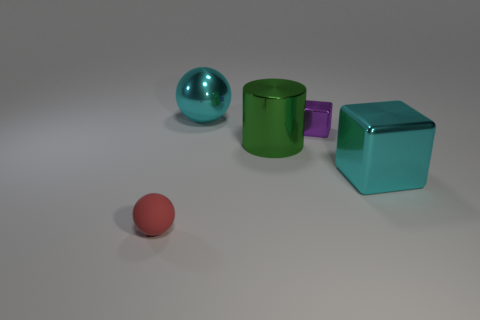Add 5 big cyan cylinders. How many objects exist? 10 Subtract all balls. How many objects are left? 3 Add 1 large metal spheres. How many large metal spheres are left? 2 Add 4 small metal things. How many small metal things exist? 5 Subtract 1 purple blocks. How many objects are left? 4 Subtract all large purple metal cylinders. Subtract all large cyan shiny spheres. How many objects are left? 4 